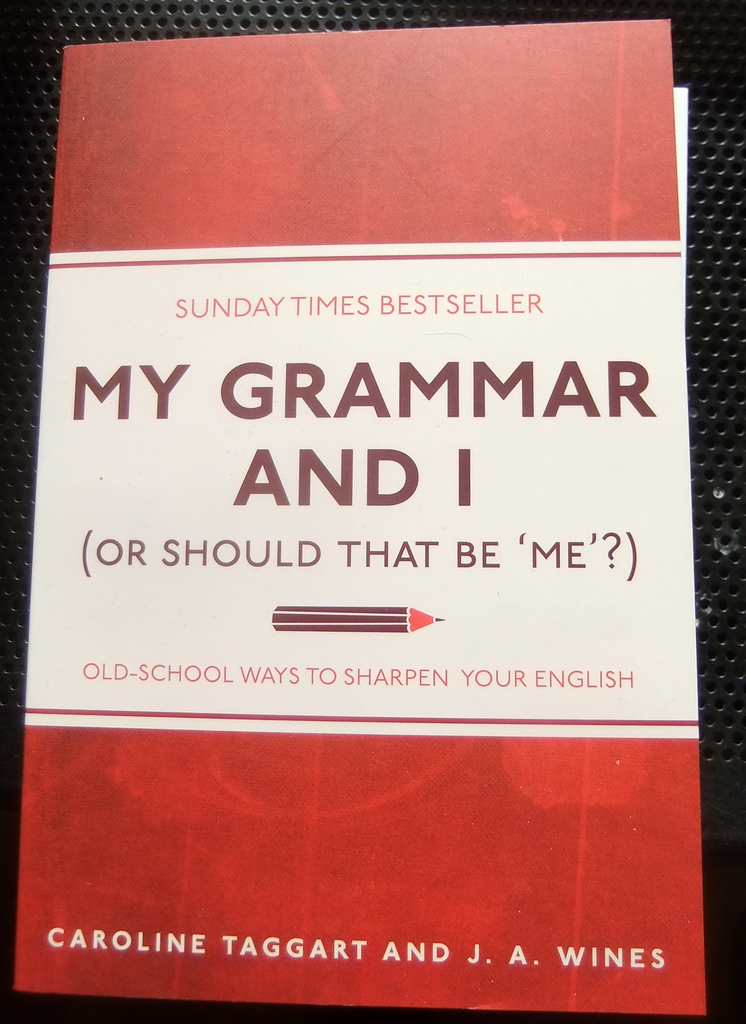How does the design of the book cover help in communicating its contents? The book cover utilizes a clear, bold red background to draw attention, while the contrasting white text ensures high readability. The use of a directional arrow pointing towards the subtitle conveys a message of guidance and correction, symbolically representing the book's purpose to direct and refine the reader's English skills. The overall minimalist design with selective use of color emphasizes clarity and straightforwardness, mirroring the way the book aims to simplify complex grammar rules for the reader. 